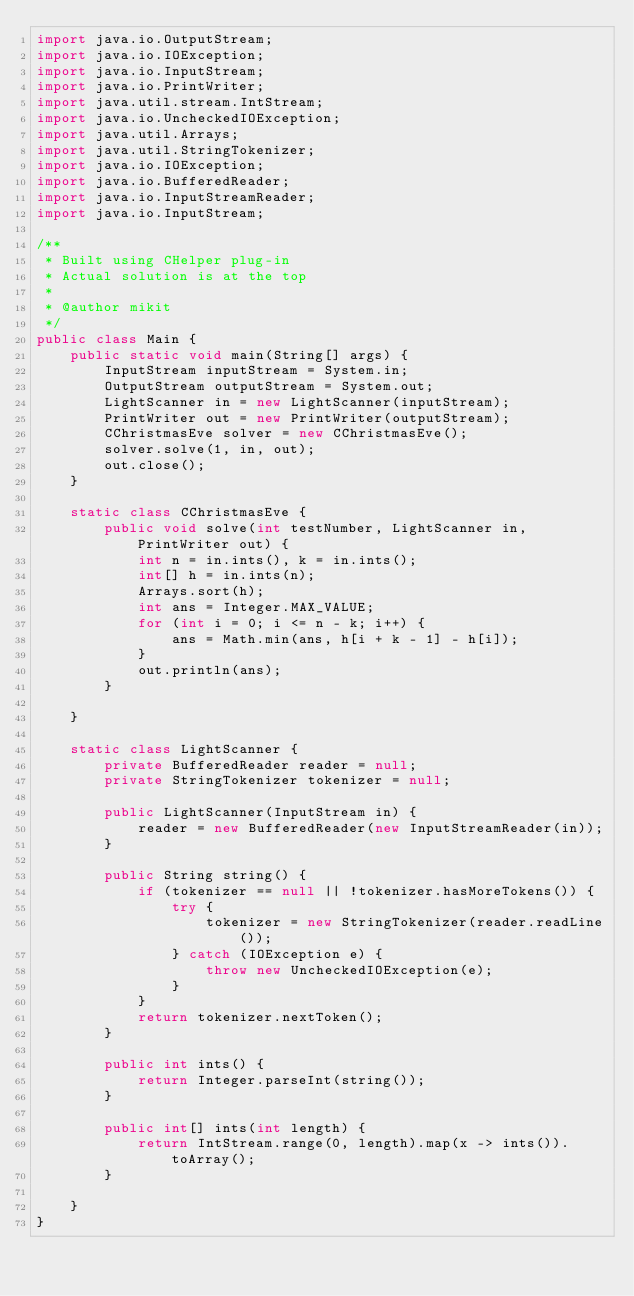<code> <loc_0><loc_0><loc_500><loc_500><_Java_>import java.io.OutputStream;
import java.io.IOException;
import java.io.InputStream;
import java.io.PrintWriter;
import java.util.stream.IntStream;
import java.io.UncheckedIOException;
import java.util.Arrays;
import java.util.StringTokenizer;
import java.io.IOException;
import java.io.BufferedReader;
import java.io.InputStreamReader;
import java.io.InputStream;

/**
 * Built using CHelper plug-in
 * Actual solution is at the top
 *
 * @author mikit
 */
public class Main {
    public static void main(String[] args) {
        InputStream inputStream = System.in;
        OutputStream outputStream = System.out;
        LightScanner in = new LightScanner(inputStream);
        PrintWriter out = new PrintWriter(outputStream);
        CChristmasEve solver = new CChristmasEve();
        solver.solve(1, in, out);
        out.close();
    }

    static class CChristmasEve {
        public void solve(int testNumber, LightScanner in, PrintWriter out) {
            int n = in.ints(), k = in.ints();
            int[] h = in.ints(n);
            Arrays.sort(h);
            int ans = Integer.MAX_VALUE;
            for (int i = 0; i <= n - k; i++) {
                ans = Math.min(ans, h[i + k - 1] - h[i]);
            }
            out.println(ans);
        }

    }

    static class LightScanner {
        private BufferedReader reader = null;
        private StringTokenizer tokenizer = null;

        public LightScanner(InputStream in) {
            reader = new BufferedReader(new InputStreamReader(in));
        }

        public String string() {
            if (tokenizer == null || !tokenizer.hasMoreTokens()) {
                try {
                    tokenizer = new StringTokenizer(reader.readLine());
                } catch (IOException e) {
                    throw new UncheckedIOException(e);
                }
            }
            return tokenizer.nextToken();
        }

        public int ints() {
            return Integer.parseInt(string());
        }

        public int[] ints(int length) {
            return IntStream.range(0, length).map(x -> ints()).toArray();
        }

    }
}

</code> 